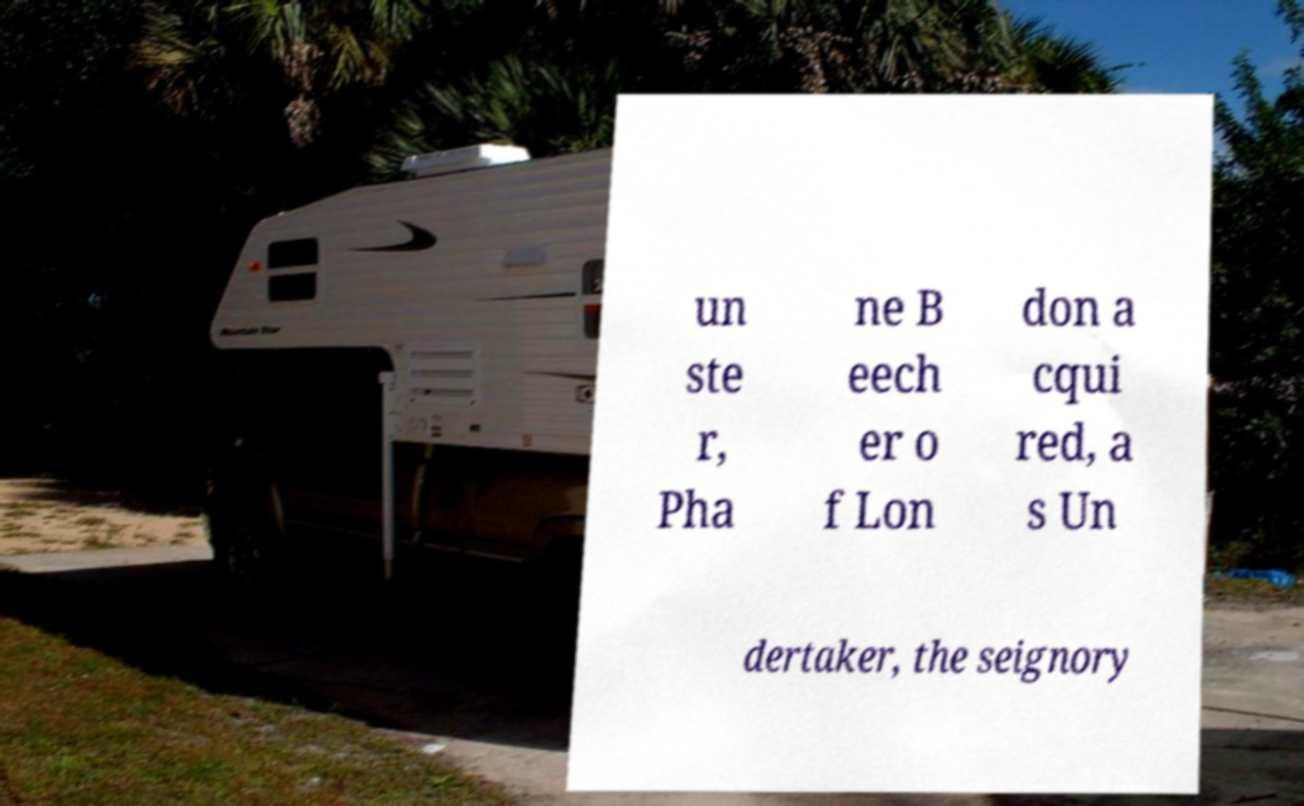Can you read and provide the text displayed in the image?This photo seems to have some interesting text. Can you extract and type it out for me? un ste r, Pha ne B eech er o f Lon don a cqui red, a s Un dertaker, the seignory 